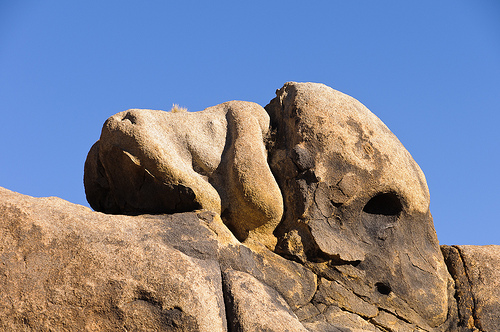<image>
Can you confirm if the rock is on the rock? Yes. Looking at the image, I can see the rock is positioned on top of the rock, with the rock providing support. 